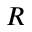Convert formula to latex. <formula><loc_0><loc_0><loc_500><loc_500>R</formula> 